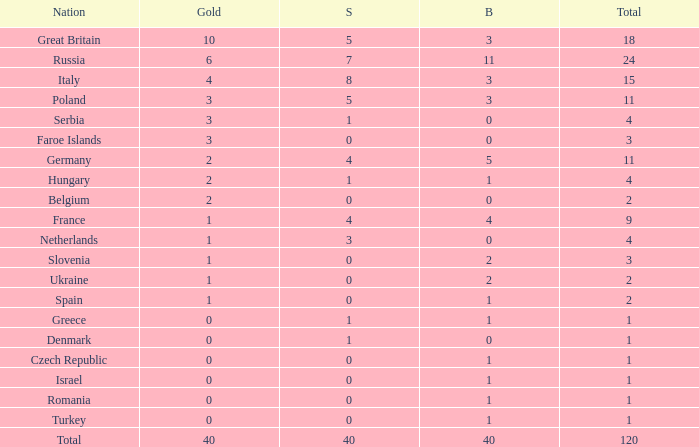What is the average Gold entry for the Netherlands that also has a Bronze entry that is greater than 0? None. 